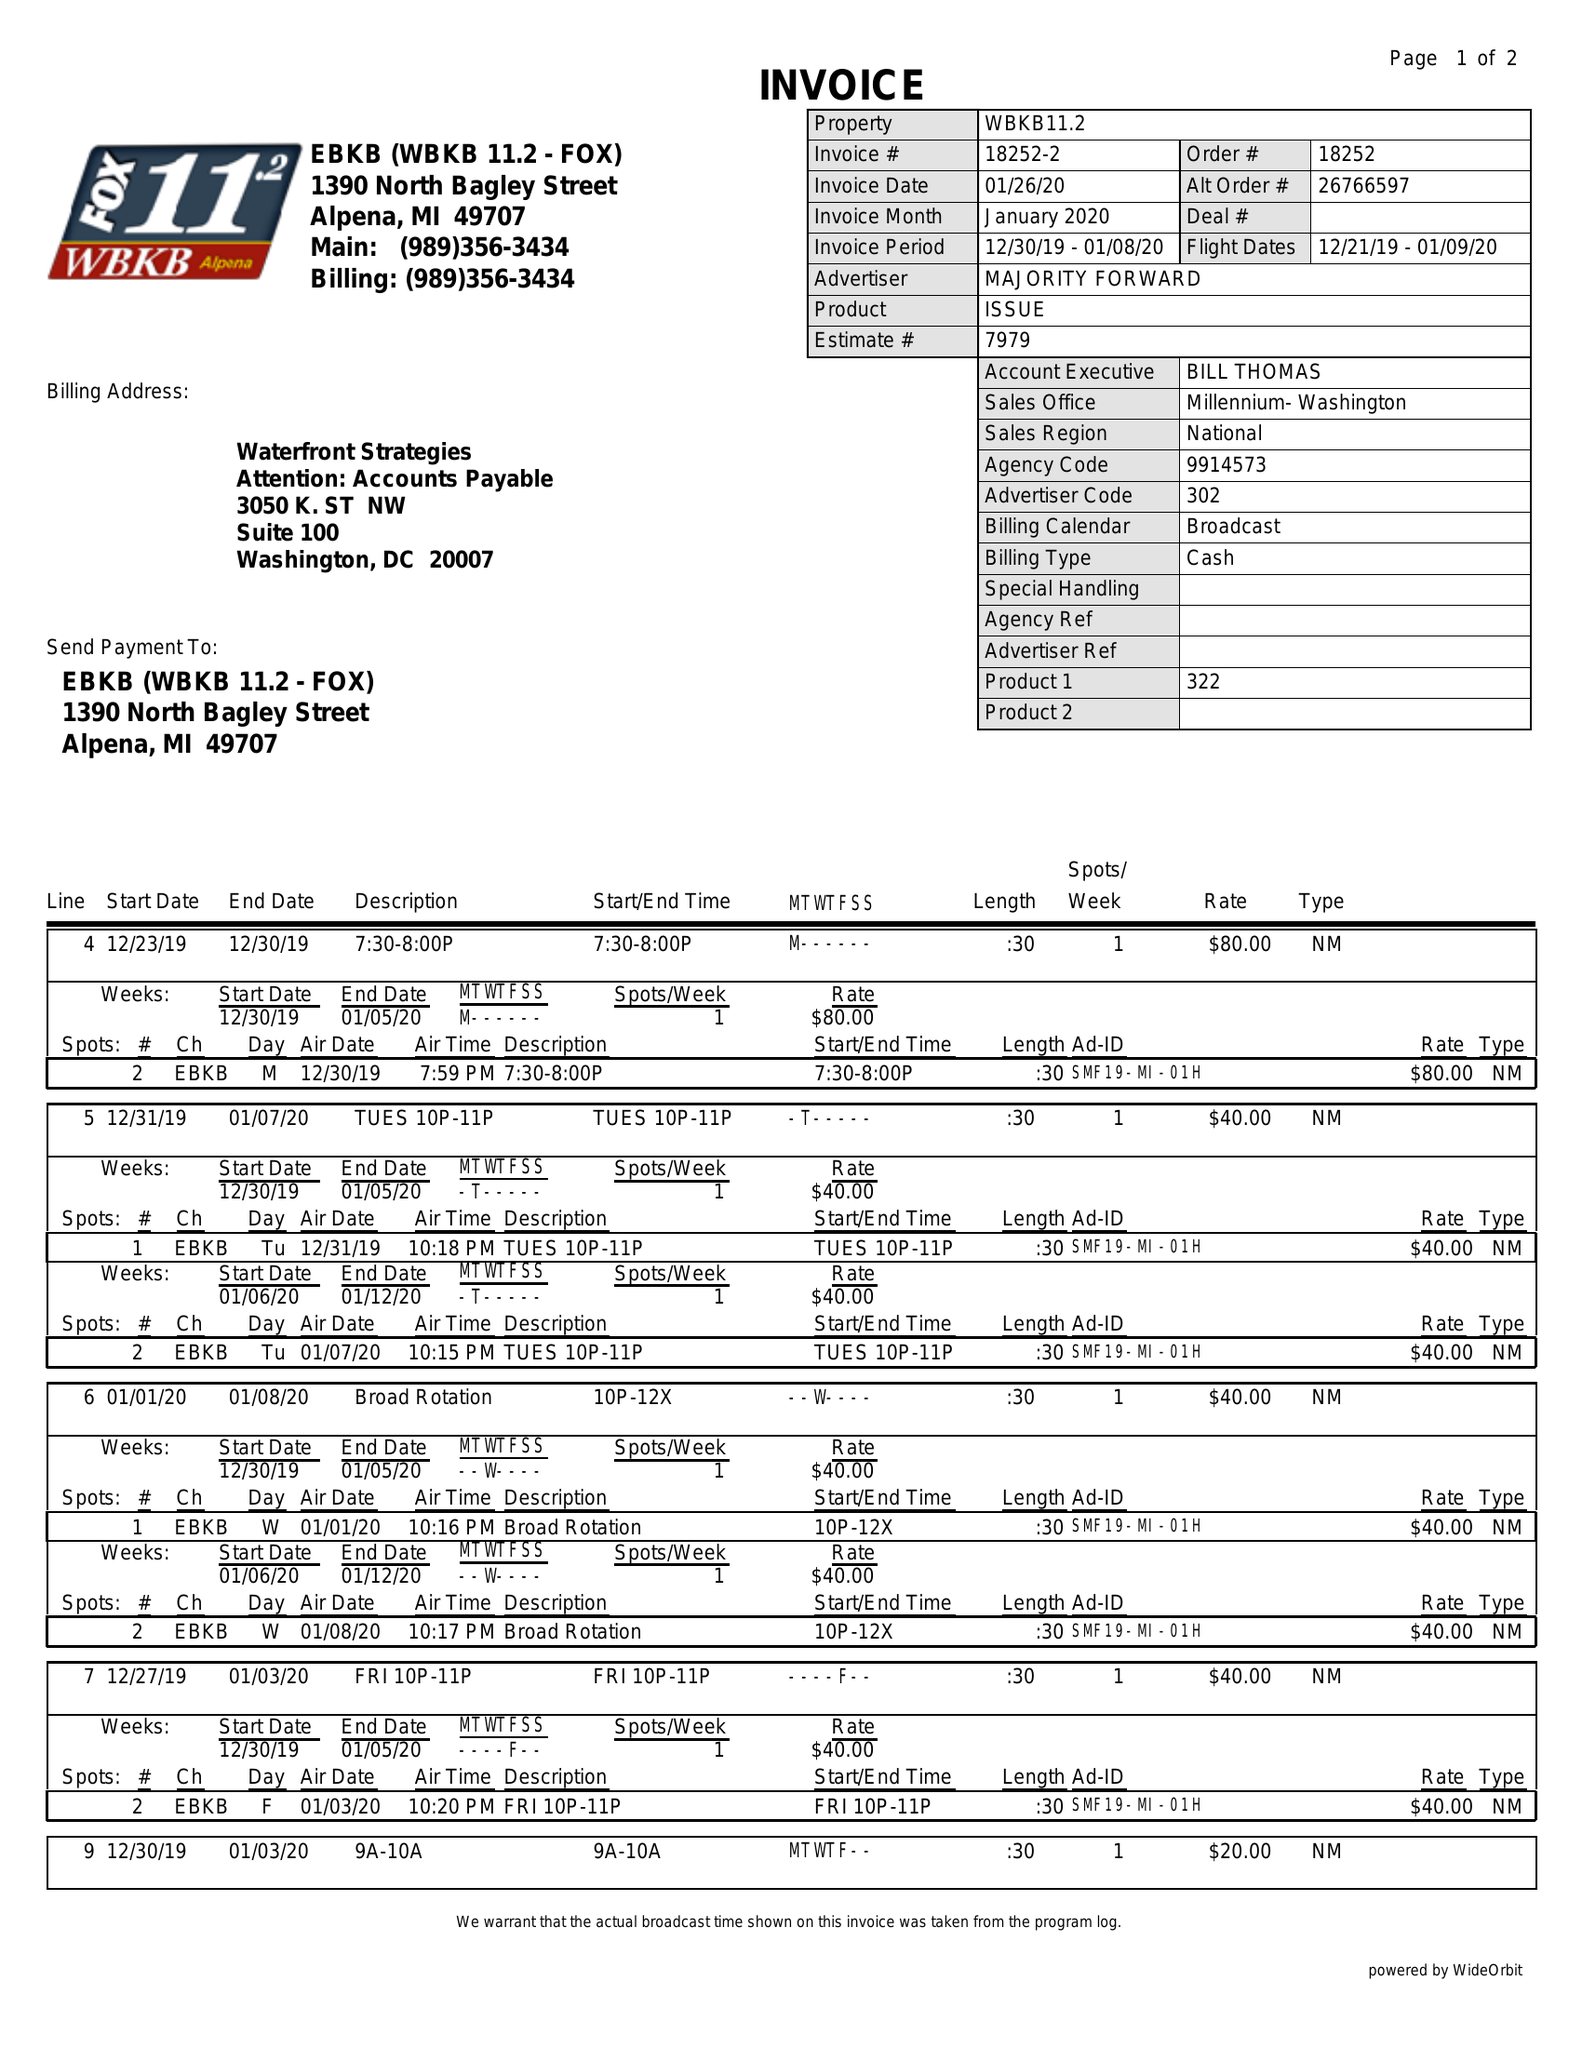What is the value for the advertiser?
Answer the question using a single word or phrase. MAJORITY FORWARD 